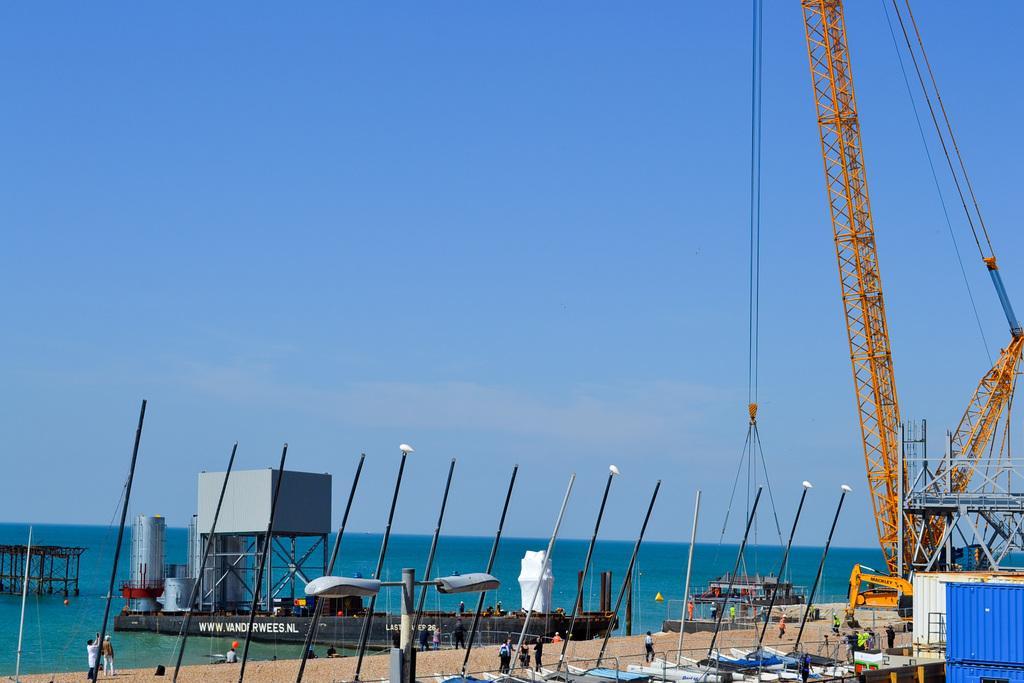Describe this image in one or two sentences. In this image there is a metal structure on the river and there are a few metal structures and a few objects on the boat, which is on the river. There is a ship hanging on the hook of a crane. In the foreground of the image there are a few metal structures, rods, few boats and a few people are walking. 